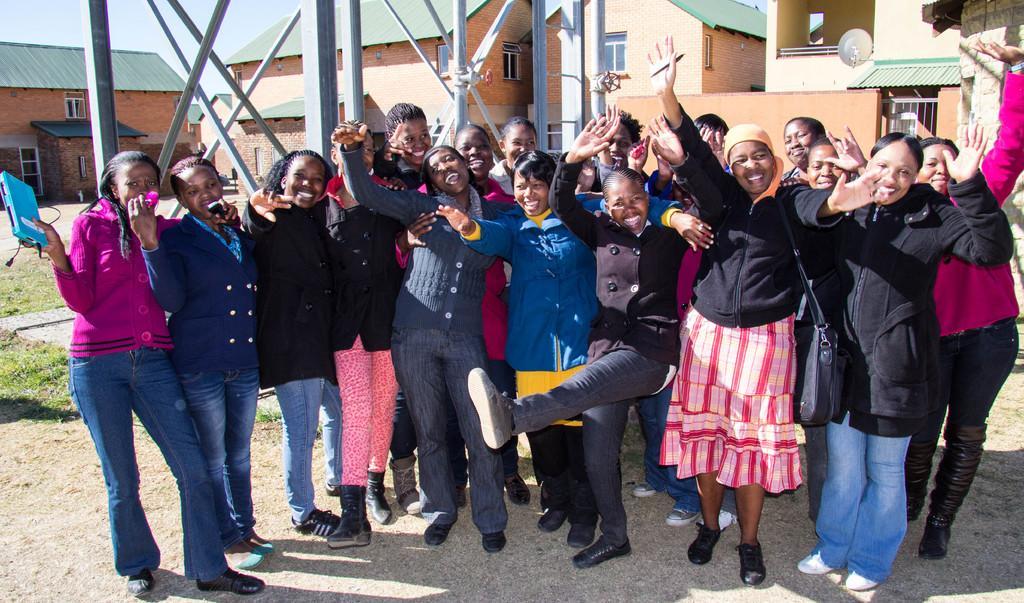Describe this image in one or two sentences. In this picture we can see a group of people smiling and standing on the ground and some objects and at the back of them we can see rods, wheels, dish antenna, buildings with windows and in the background we can see the sky. 